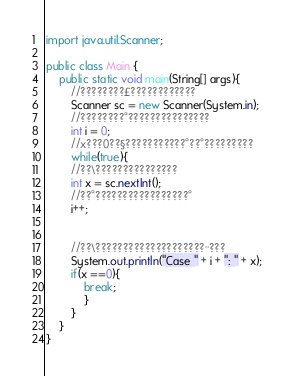<code> <loc_0><loc_0><loc_500><loc_500><_Java_>import java.util.Scanner;

public class Main {
	public static void main(String[] args){
		//????????£????????????
		Scanner sc = new Scanner(System.in);
		//????????°???????????????
		int i = 0;
		//x???0??§???????????°??°?????????
		while(true){
		//??\???????????????
		int x = sc.nextInt();
		//??°?????????????????°
		i++;
		
		
		//??\????????????????????¨???
		System.out.println("Case " + i + ": " + x);
		if(x ==0){
			break;
			}
		}
	}
}</code> 